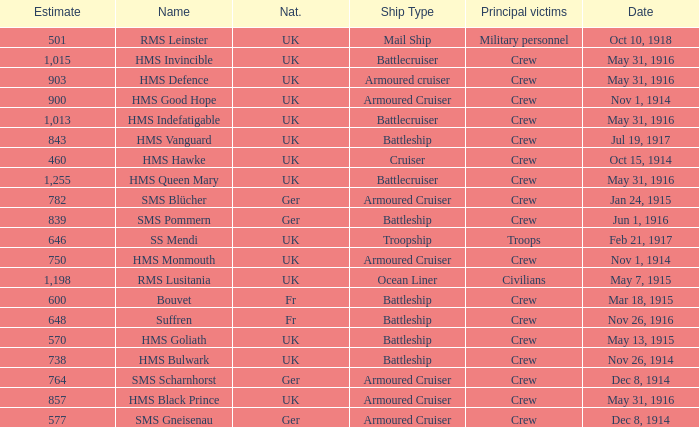What is the nationality of the ship when the principle victims are civilians? UK. 